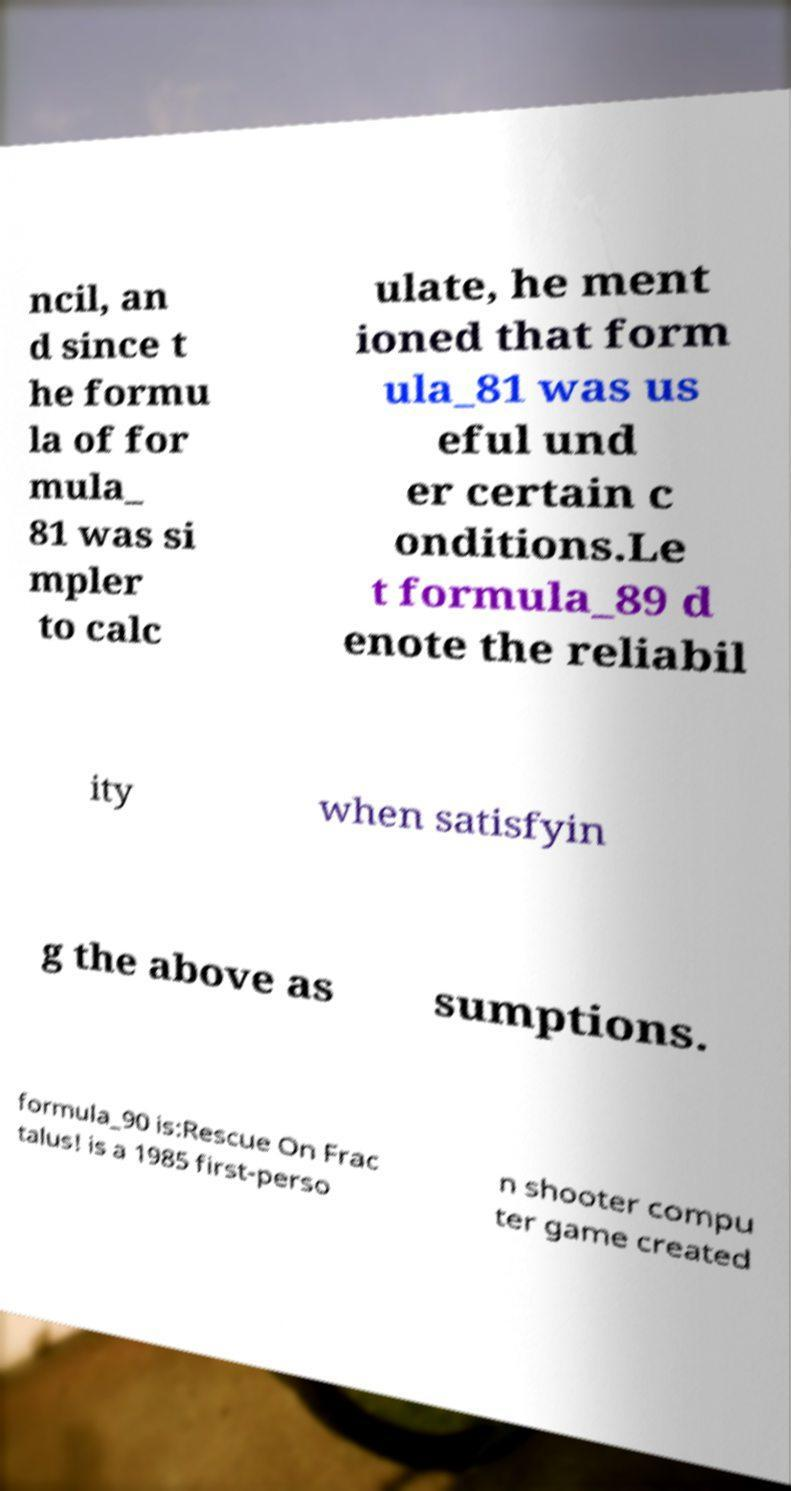What messages or text are displayed in this image? I need them in a readable, typed format. ncil, an d since t he formu la of for mula_ 81 was si mpler to calc ulate, he ment ioned that form ula_81 was us eful und er certain c onditions.Le t formula_89 d enote the reliabil ity when satisfyin g the above as sumptions. formula_90 is:Rescue On Frac talus! is a 1985 first-perso n shooter compu ter game created 